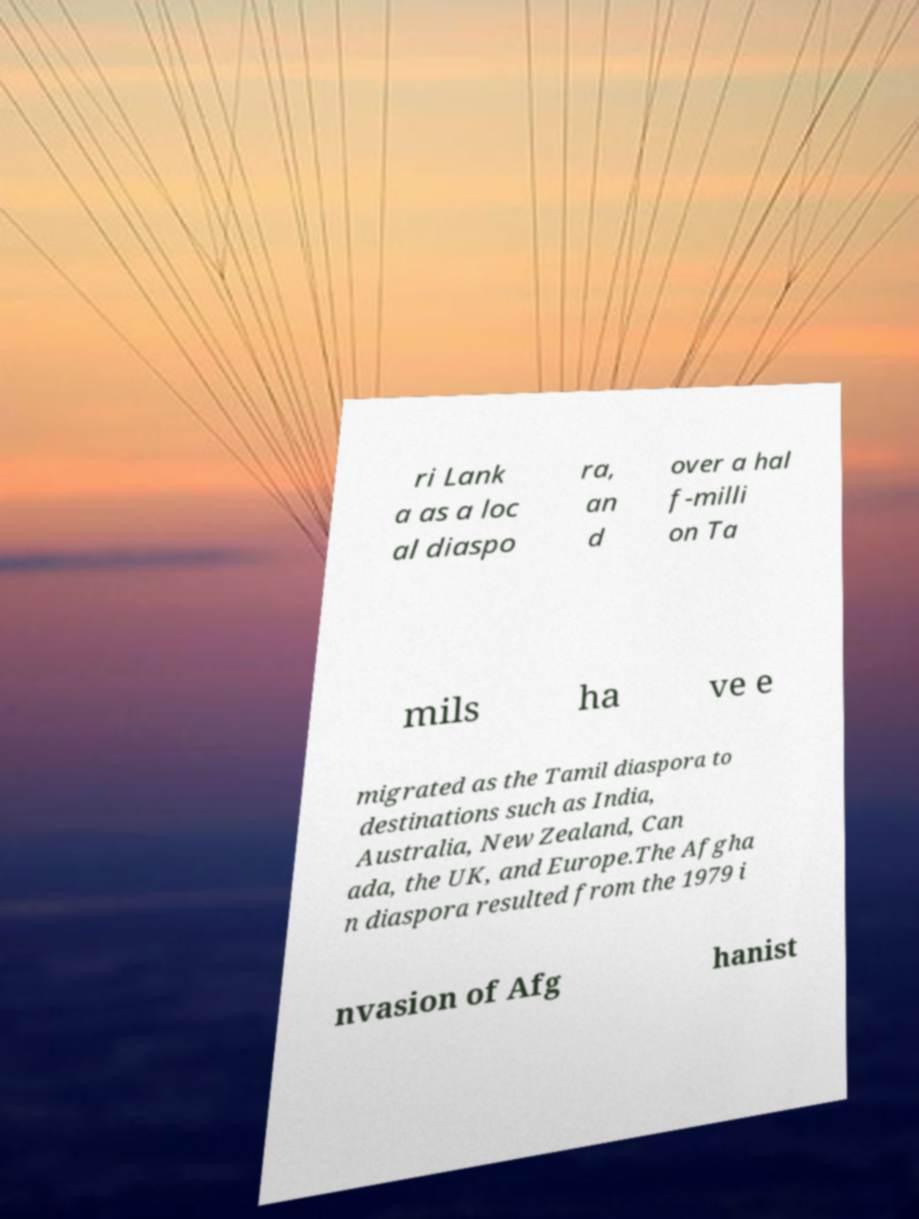Please read and relay the text visible in this image. What does it say? ri Lank a as a loc al diaspo ra, an d over a hal f-milli on Ta mils ha ve e migrated as the Tamil diaspora to destinations such as India, Australia, New Zealand, Can ada, the UK, and Europe.The Afgha n diaspora resulted from the 1979 i nvasion of Afg hanist 